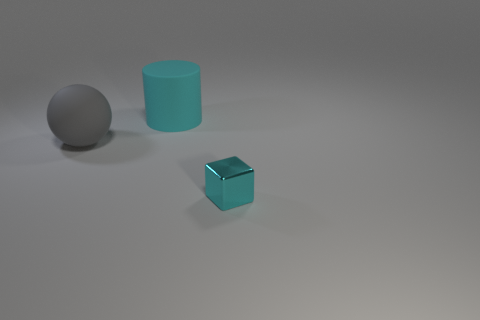Add 1 big rubber cylinders. How many objects exist? 4 Subtract 1 cylinders. How many cylinders are left? 0 Subtract all spheres. How many objects are left? 2 Add 3 large cyan matte things. How many large cyan matte things exist? 4 Subtract 1 cyan cylinders. How many objects are left? 2 Subtract all gray spheres. How many blue cylinders are left? 0 Subtract all cubes. Subtract all cylinders. How many objects are left? 1 Add 3 cyan matte things. How many cyan matte things are left? 4 